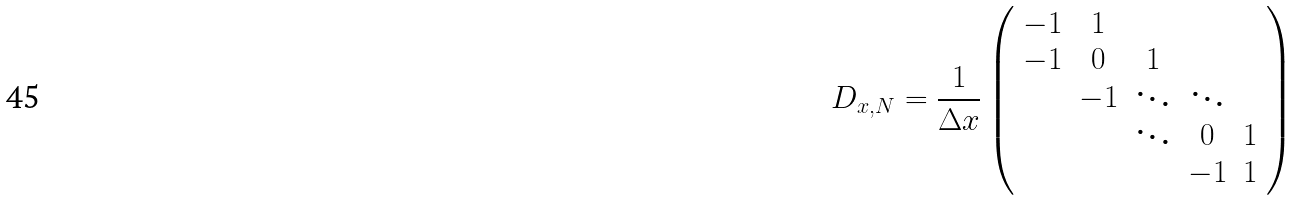<formula> <loc_0><loc_0><loc_500><loc_500>D _ { x , N } = \frac { 1 } { \Delta x } \left ( \begin{array} { c c c c c } - 1 & 1 & & & \\ - 1 & 0 & 1 & & \\ & - 1 & \ddots & \ddots & \\ & & \ddots & 0 & 1 \\ & & & - 1 & 1 \end{array} \right )</formula> 